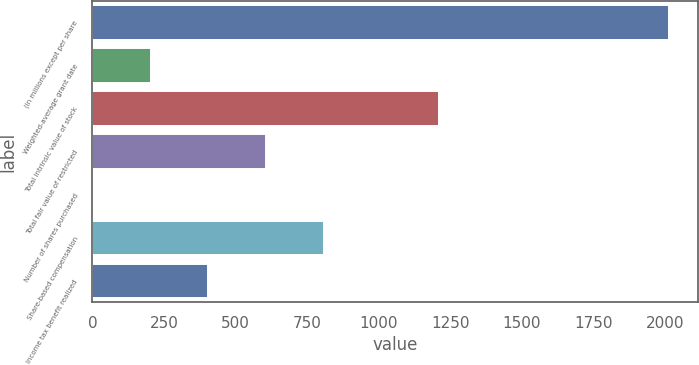<chart> <loc_0><loc_0><loc_500><loc_500><bar_chart><fcel>(in millions except per share<fcel>Weighted-average grant date<fcel>Total intrinsic value of stock<fcel>Total fair value of restricted<fcel>Number of shares purchased<fcel>Share-based compensation<fcel>Income tax benefit realized<nl><fcel>2016<fcel>203.4<fcel>1210.4<fcel>606.2<fcel>2<fcel>807.6<fcel>404.8<nl></chart> 